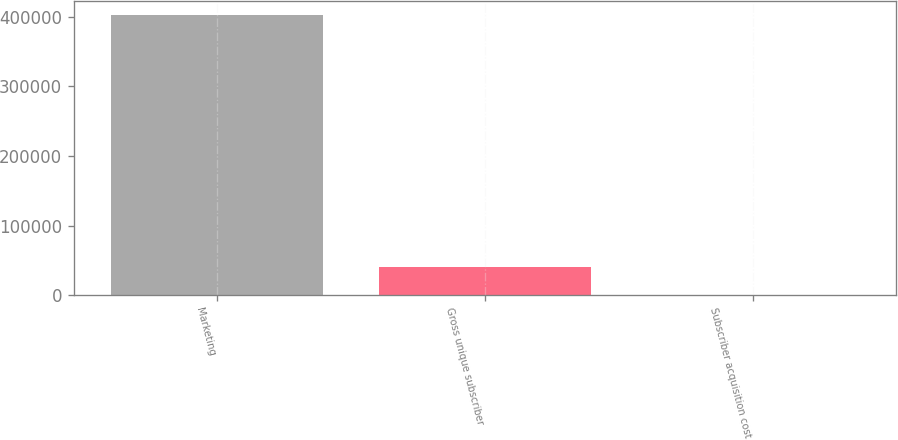<chart> <loc_0><loc_0><loc_500><loc_500><bar_chart><fcel>Marketing<fcel>Gross unique subscriber<fcel>Subscriber acquisition cost<nl><fcel>402638<fcel>40277.3<fcel>15.04<nl></chart> 